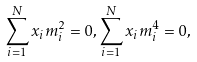<formula> <loc_0><loc_0><loc_500><loc_500>\sum _ { i = 1 } ^ { N } x _ { i } m _ { i } ^ { 2 } = 0 , \sum _ { i = 1 } ^ { N } x _ { i } m _ { i } ^ { 4 } = 0 ,</formula> 